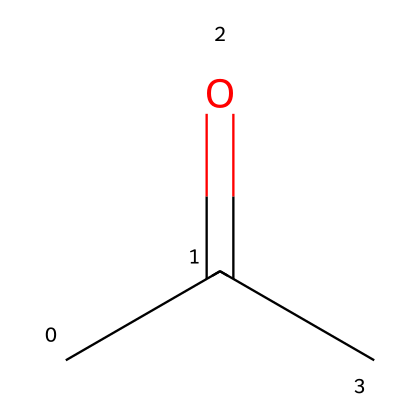What is the name of this chemical? The SMILES representation "CC(=O)C" indicates a molecule with a carbonyl group (C=O) bonded to a carbon chain. This corresponds to the common name "acetone."
Answer: acetone How many carbon atoms does this molecule have? By analyzing the SMILES, "CC(=O)C" contains three carbon atoms; two from the "CC" portion and one from the "C" adjacent to the carbonyl group.
Answer: 3 What functional group is present in this chemical? The representation shows a carbonyl group (=O) connected to two carbon atoms, which is characteristic of ketones. Thus, the functional group present is a carbonyl group.
Answer: carbonyl group How many hydrogen atoms are attached to the carbon atoms in this molecule? For the three carbon atoms in acetone, we can assign hydrogen atoms based on tetravalency. The two terminal carbon atoms are each bonded to three hydrogen atoms, while the central carbon is bonded to one hydrogen and the carbonyl oxygen, totaling seven hydrogen atoms.
Answer: 6 What type of chemical is acetone classified as? Acetone has a carbonyl group (C=O) between two carbon chains, classifying it as a ketone, distinct from aldehydes and alcohols by the placement of the carbonyl group.
Answer: ketone What is the general formula for ketones? Ketones are typically represented by the formula CnH2nO. In the case of three carbon atoms (n=3), the formula becomes C3H6O, reflecting the typical structure of ketones.
Answer: CnH2nO 